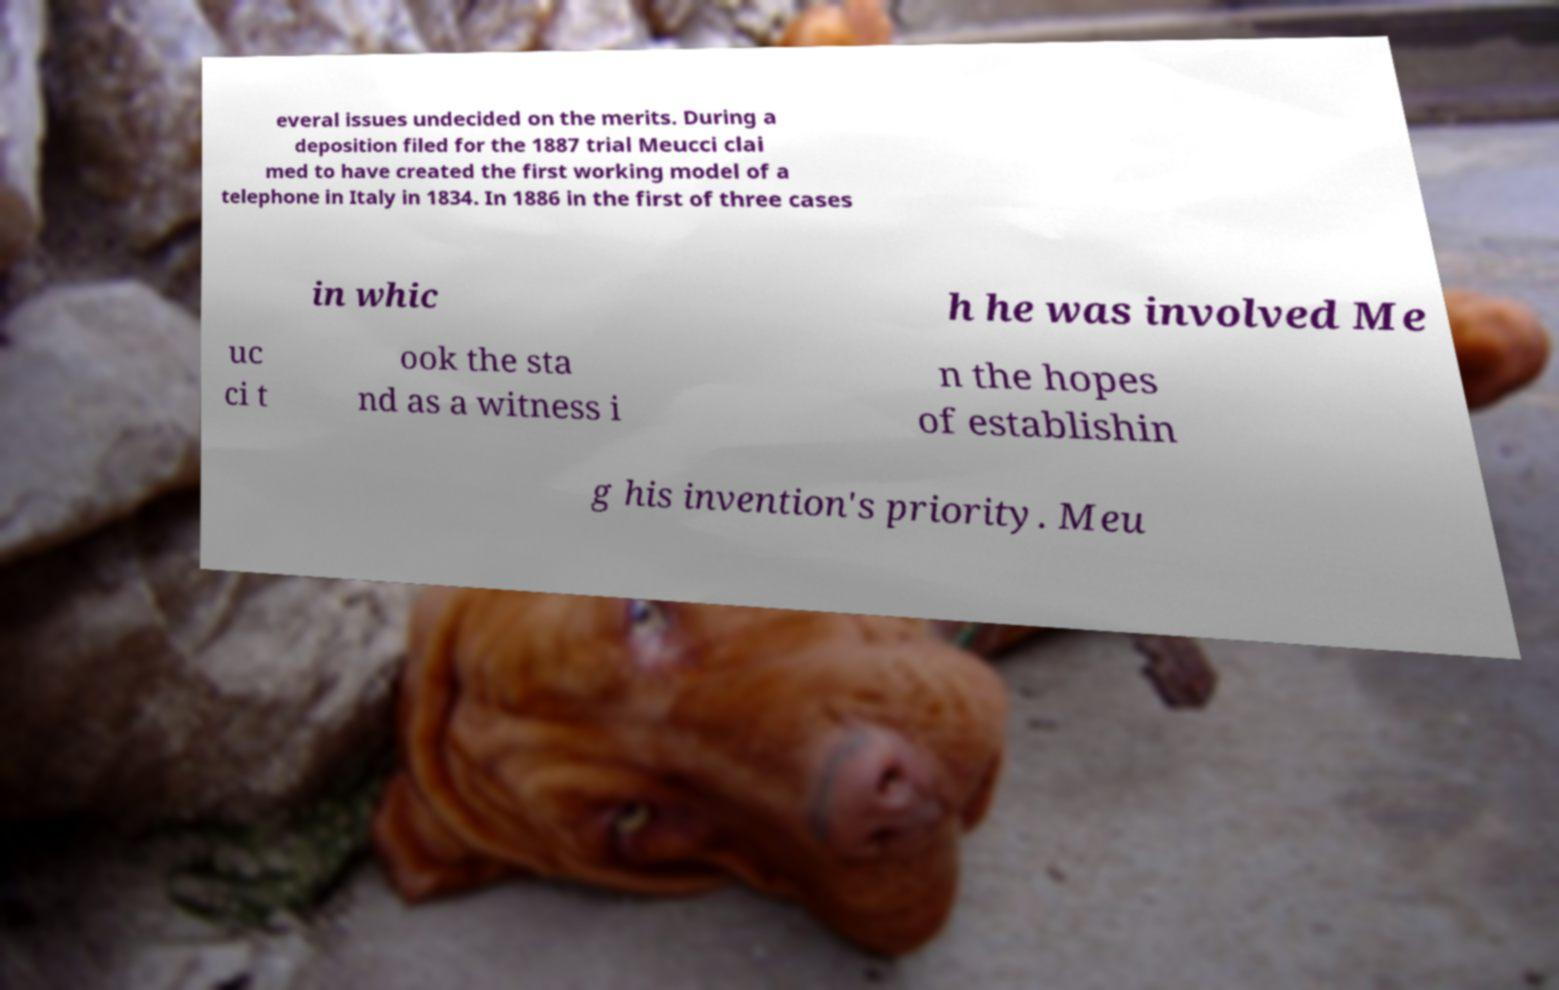Can you read and provide the text displayed in the image?This photo seems to have some interesting text. Can you extract and type it out for me? everal issues undecided on the merits. During a deposition filed for the 1887 trial Meucci clai med to have created the first working model of a telephone in Italy in 1834. In 1886 in the first of three cases in whic h he was involved Me uc ci t ook the sta nd as a witness i n the hopes of establishin g his invention's priority. Meu 